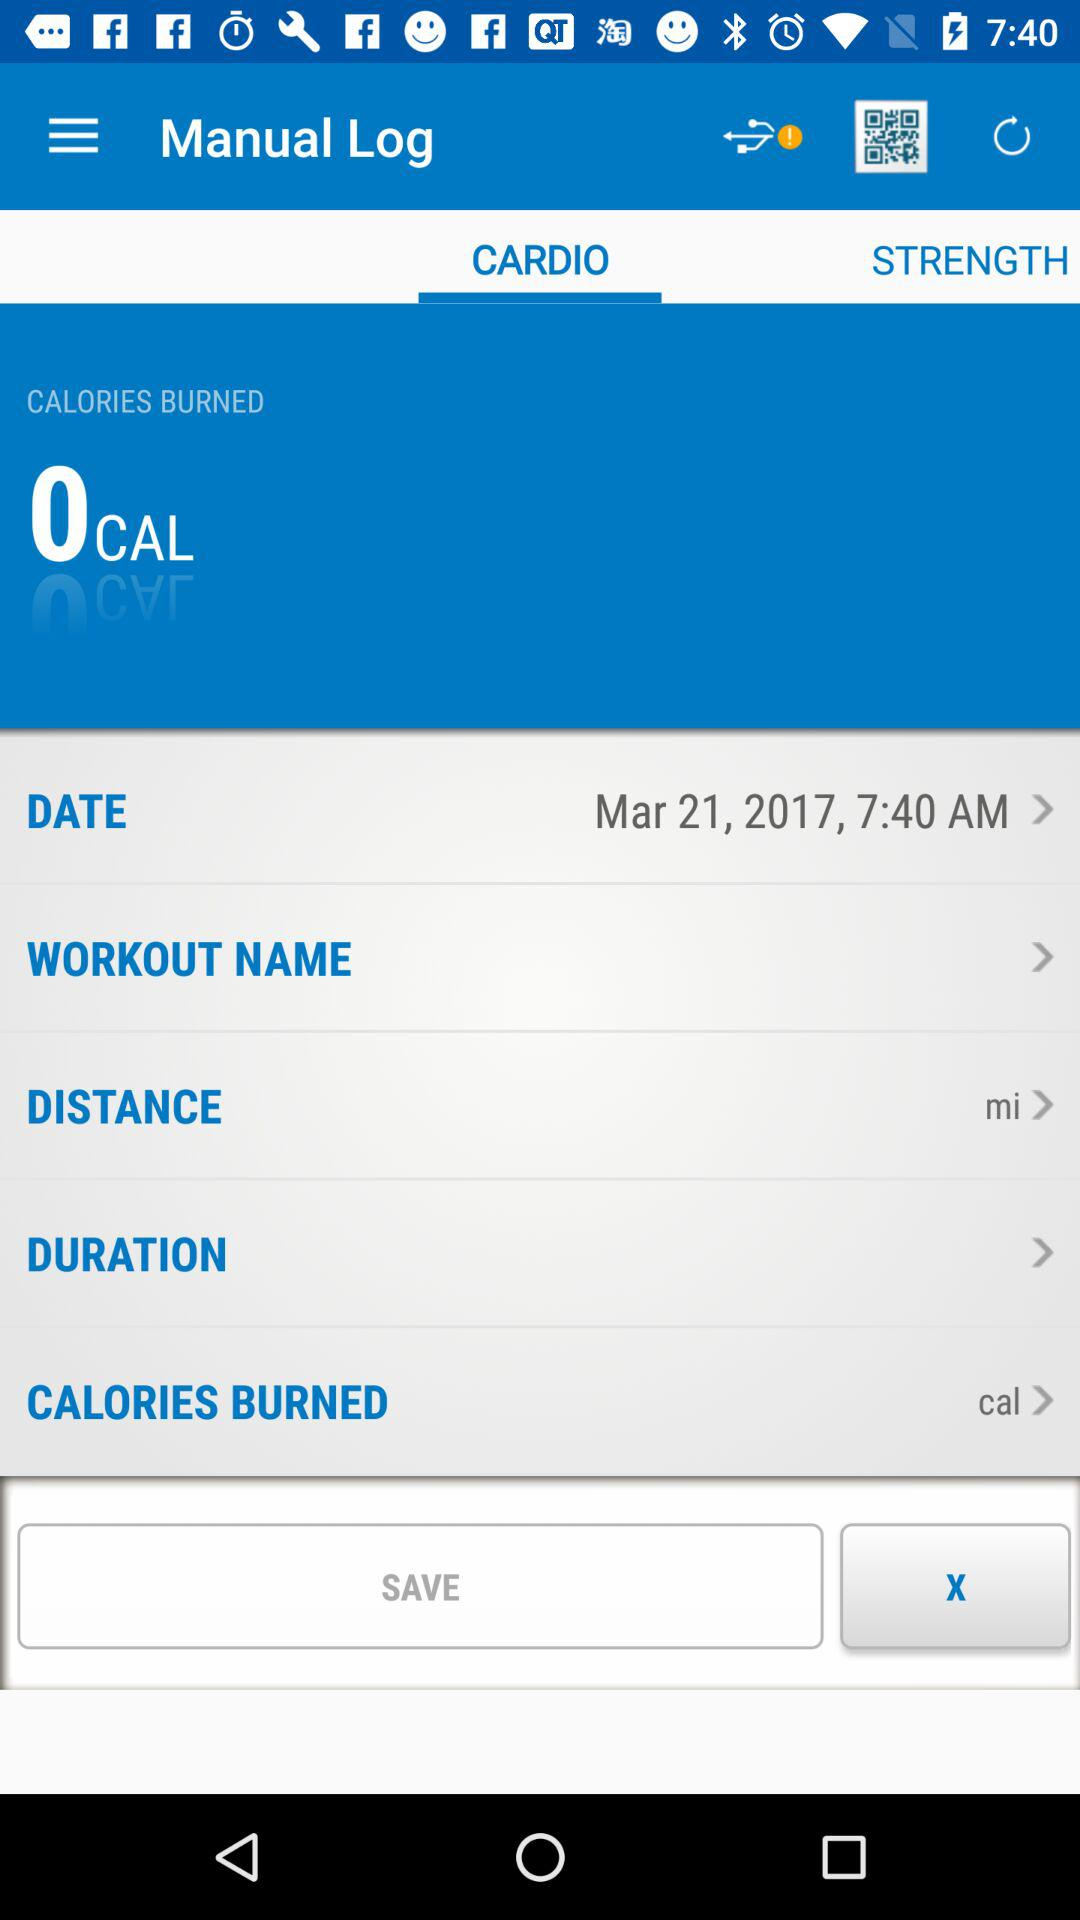Which tab is selected? The selected tab is "CARDIO". 